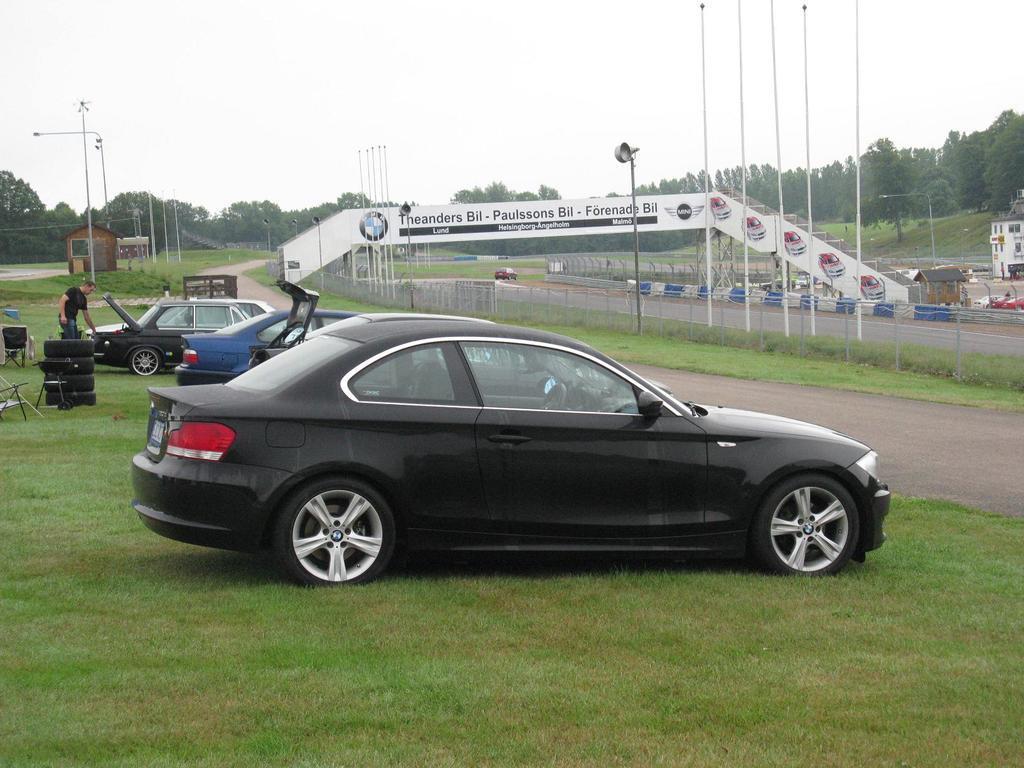In one or two sentences, can you explain what this image depicts? In the picture I can see these cars are parked on the grass and I can see a person, tires are placed on the left side of the image, I can see poles, hoardings, light poles, banners, road, trees and the sky in the background. 